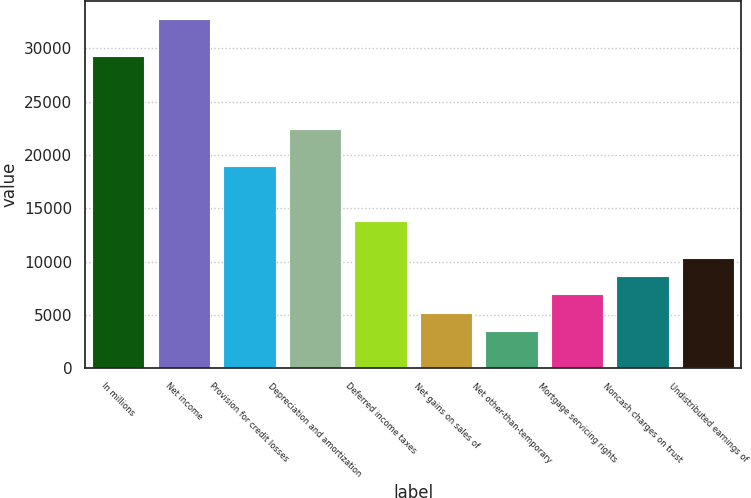Convert chart. <chart><loc_0><loc_0><loc_500><loc_500><bar_chart><fcel>In millions<fcel>Net income<fcel>Provision for credit losses<fcel>Depreciation and amortization<fcel>Deferred income taxes<fcel>Net gains on sales of<fcel>Net other-than-temporary<fcel>Mortgage servicing rights<fcel>Noncash charges on trust<fcel>Undistributed earnings of<nl><fcel>29331.1<fcel>32779.7<fcel>18985.3<fcel>22433.9<fcel>13812.4<fcel>5190.9<fcel>3466.6<fcel>6915.2<fcel>8639.5<fcel>10363.8<nl></chart> 